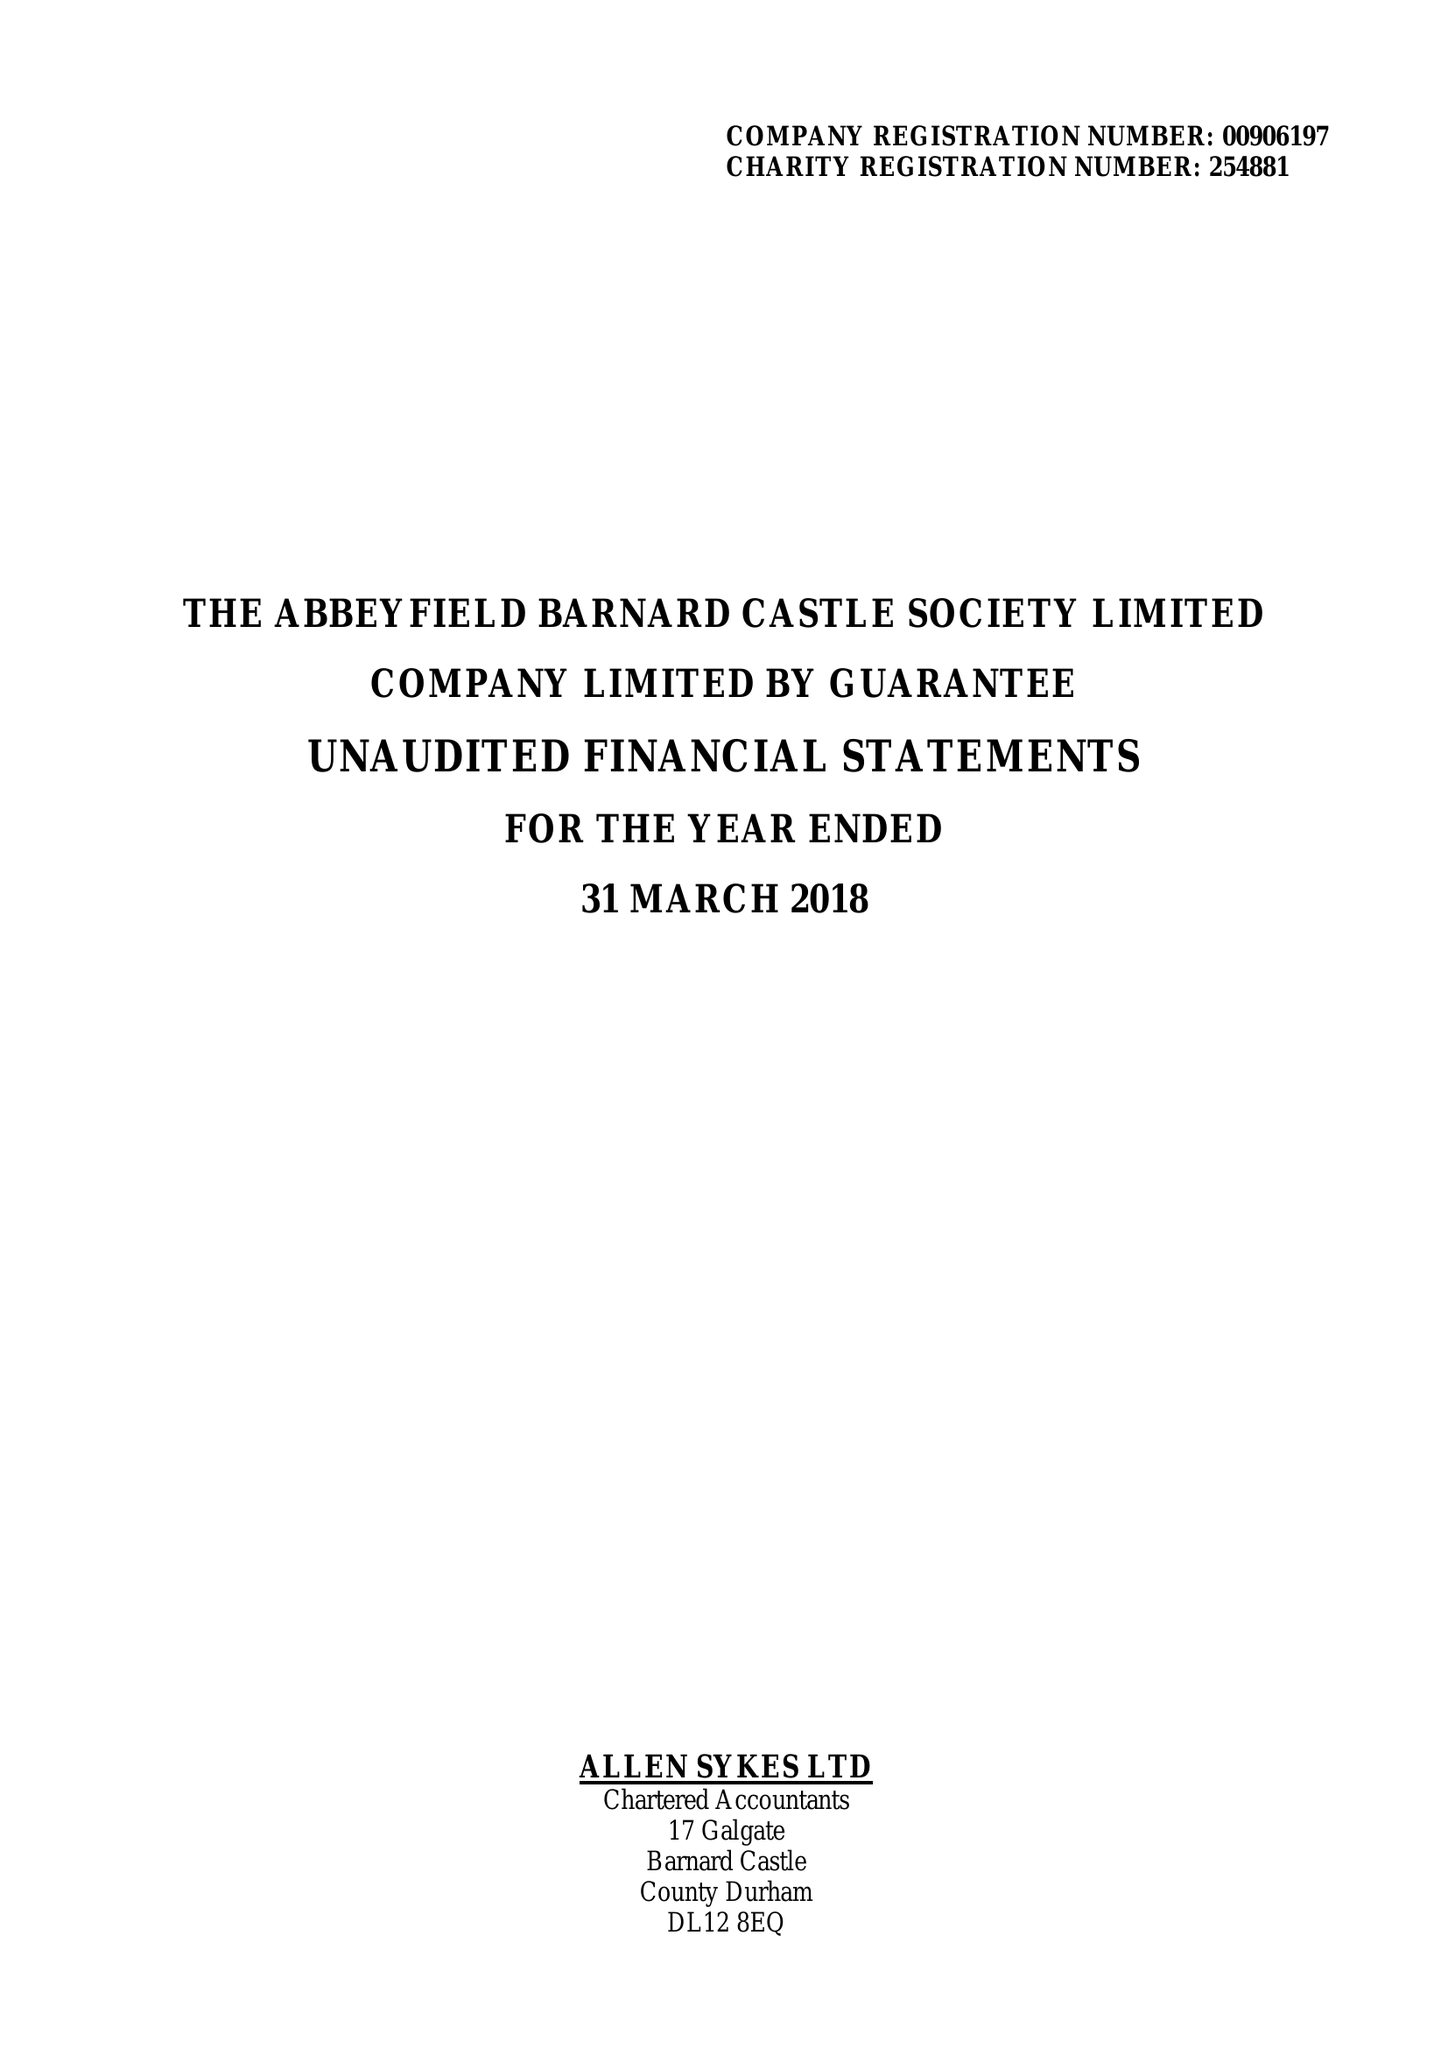What is the value for the report_date?
Answer the question using a single word or phrase. 2018-03-31 